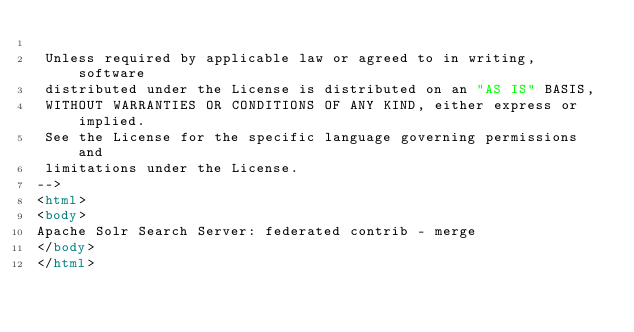<code> <loc_0><loc_0><loc_500><loc_500><_HTML_>
 Unless required by applicable law or agreed to in writing, software
 distributed under the License is distributed on an "AS IS" BASIS,
 WITHOUT WARRANTIES OR CONDITIONS OF ANY KIND, either express or implied.
 See the License for the specific language governing permissions and
 limitations under the License.
-->
<html>
<body>
Apache Solr Search Server: federated contrib - merge
</body>
</html>
</code> 